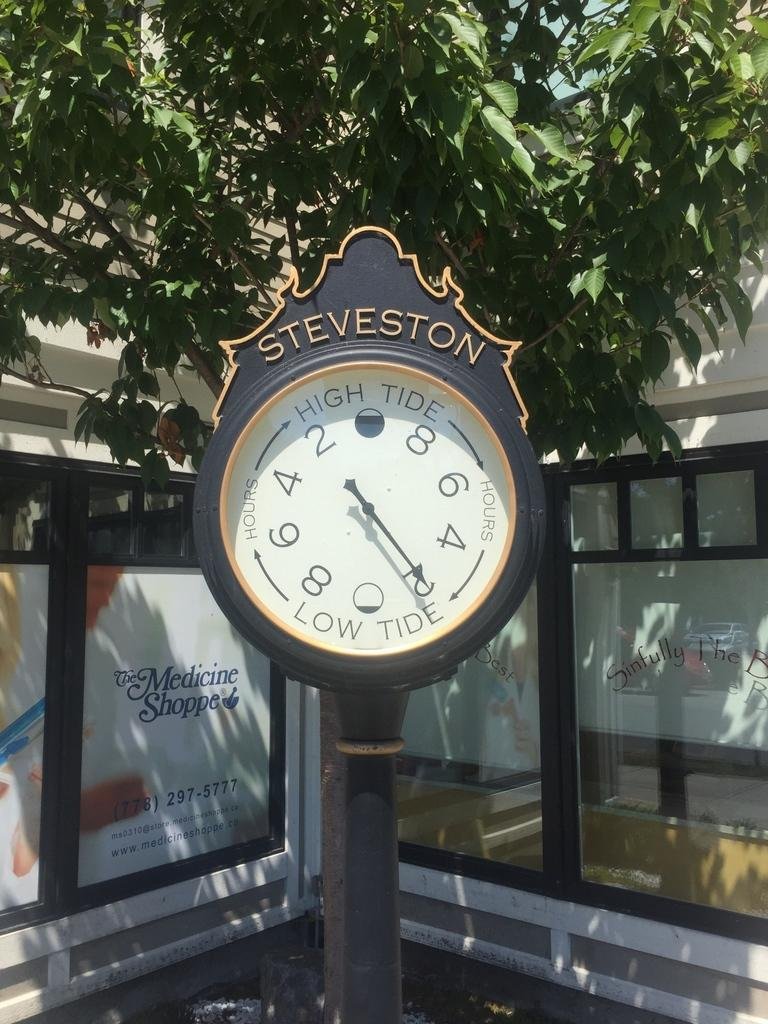<image>
Summarize the visual content of the image. An antique Steveston sidewalk clock is in front of an advertisement for The Medicine Shoppe. 